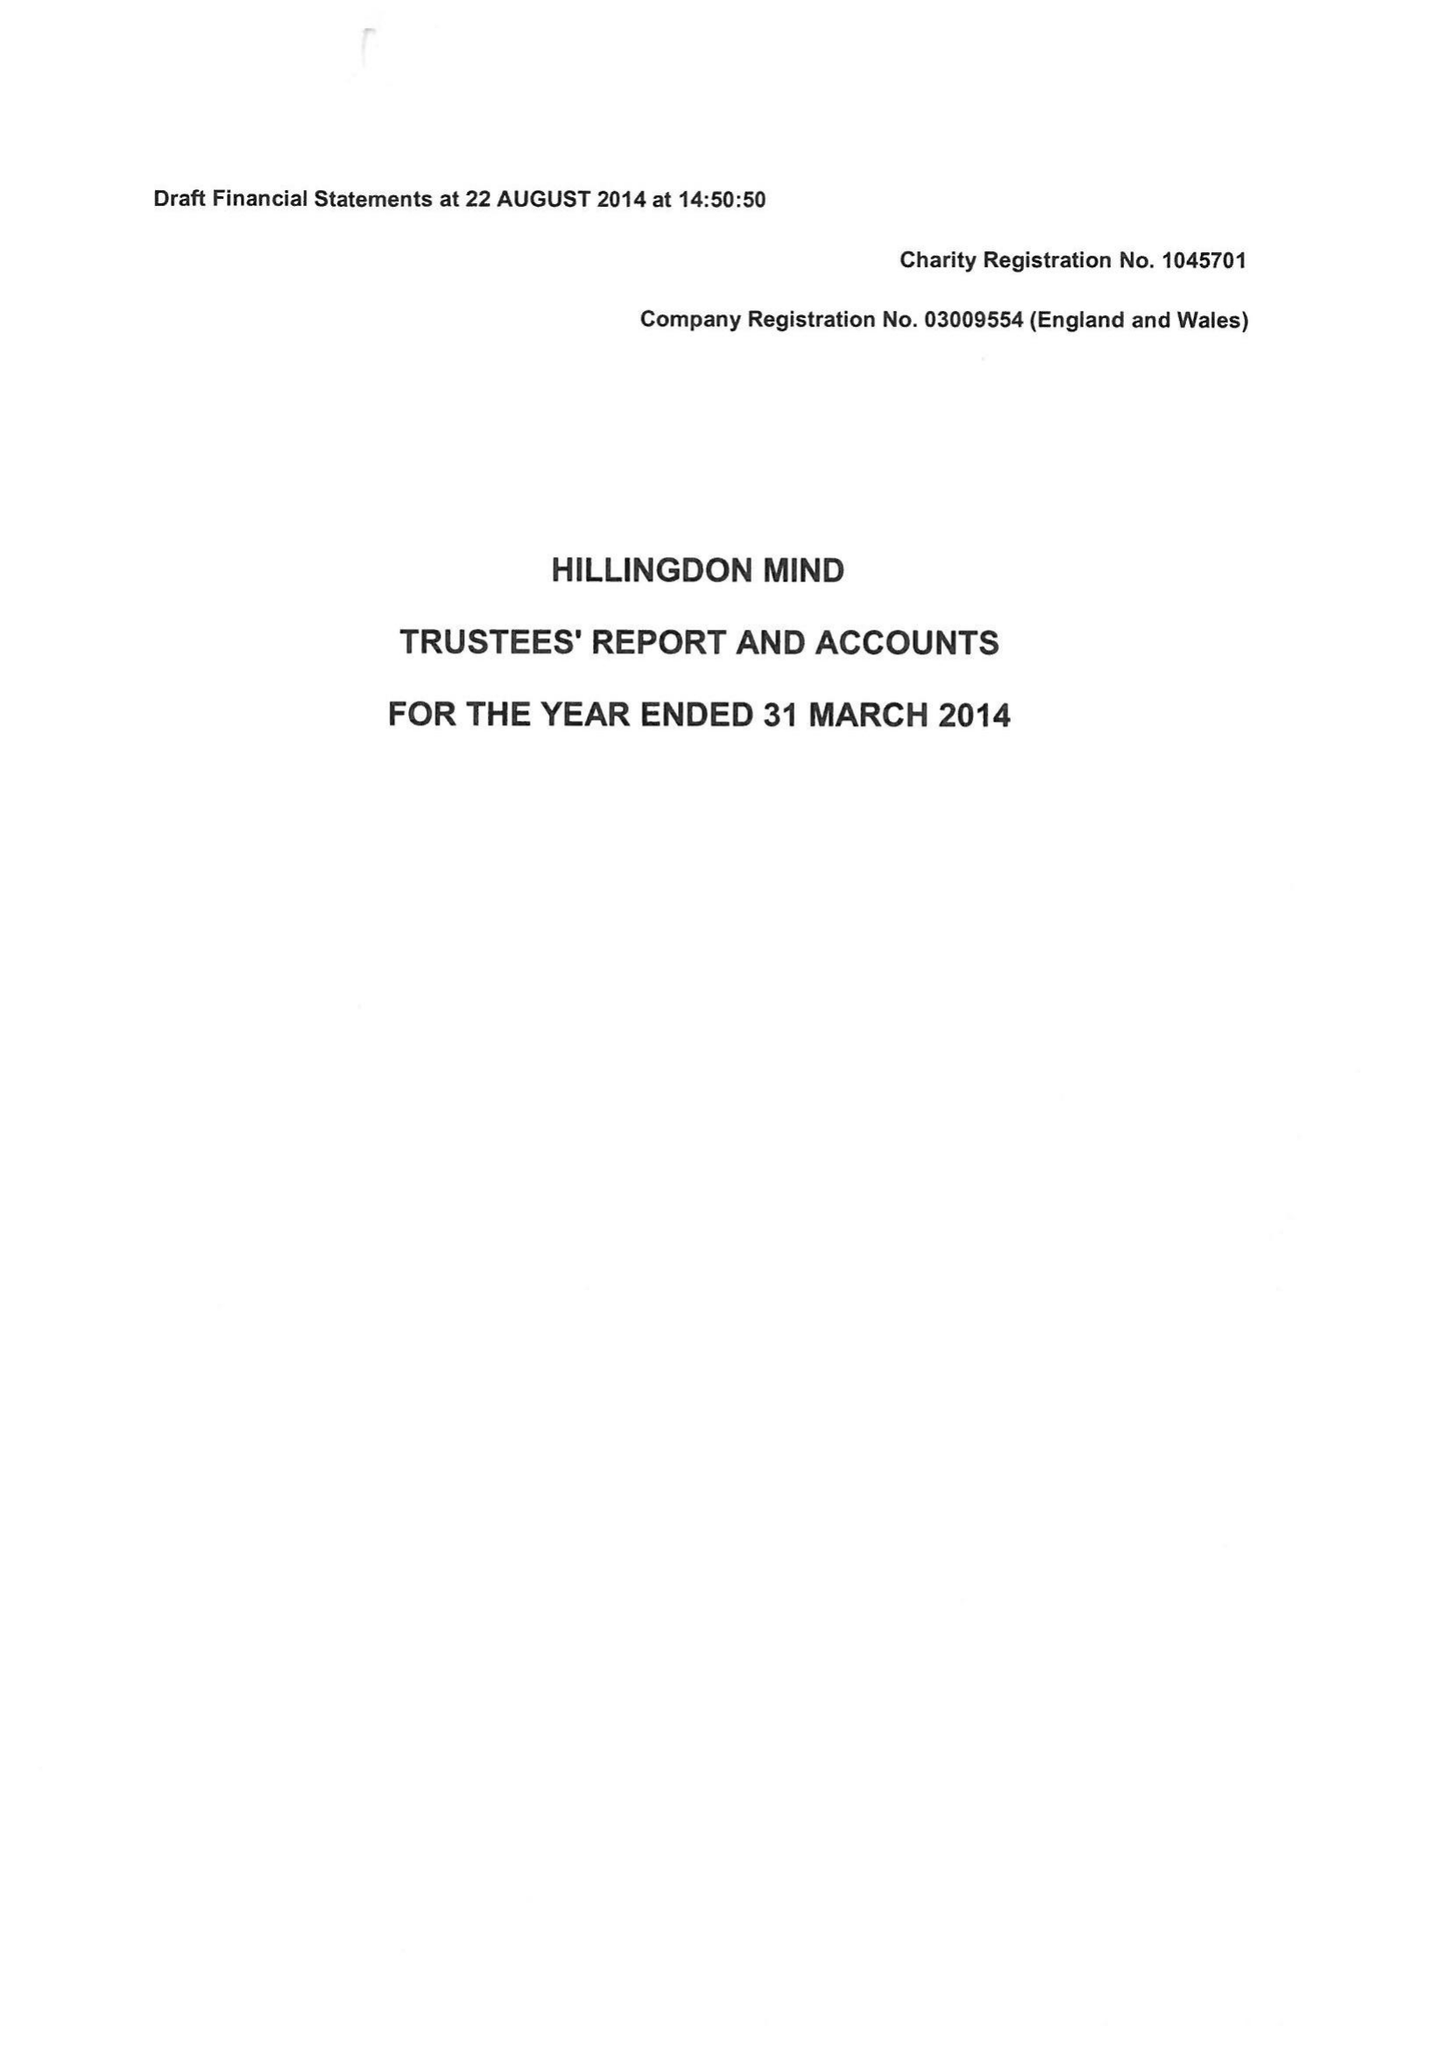What is the value for the income_annually_in_british_pounds?
Answer the question using a single word or phrase. 410998.00 